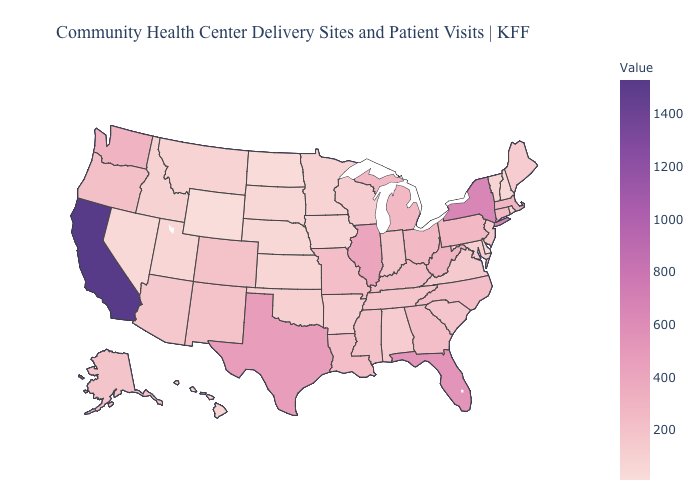Does Oklahoma have a lower value than Massachusetts?
Be succinct. Yes. Among the states that border Pennsylvania , does Maryland have the lowest value?
Give a very brief answer. No. Which states have the lowest value in the Northeast?
Answer briefly. New Hampshire. Which states hav the highest value in the South?
Keep it brief. Florida. Does California have the highest value in the USA?
Short answer required. Yes. Does Michigan have the lowest value in the MidWest?
Write a very short answer. No. Does Wyoming have the lowest value in the USA?
Short answer required. Yes. 